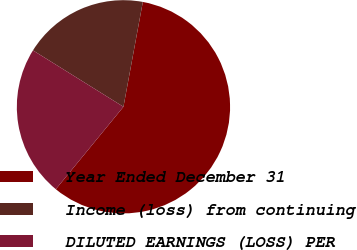Convert chart to OTSL. <chart><loc_0><loc_0><loc_500><loc_500><pie_chart><fcel>Year Ended December 31<fcel>Income (loss) from continuing<fcel>DILUTED EARNINGS (LOSS) PER<nl><fcel>58.03%<fcel>19.04%<fcel>22.94%<nl></chart> 